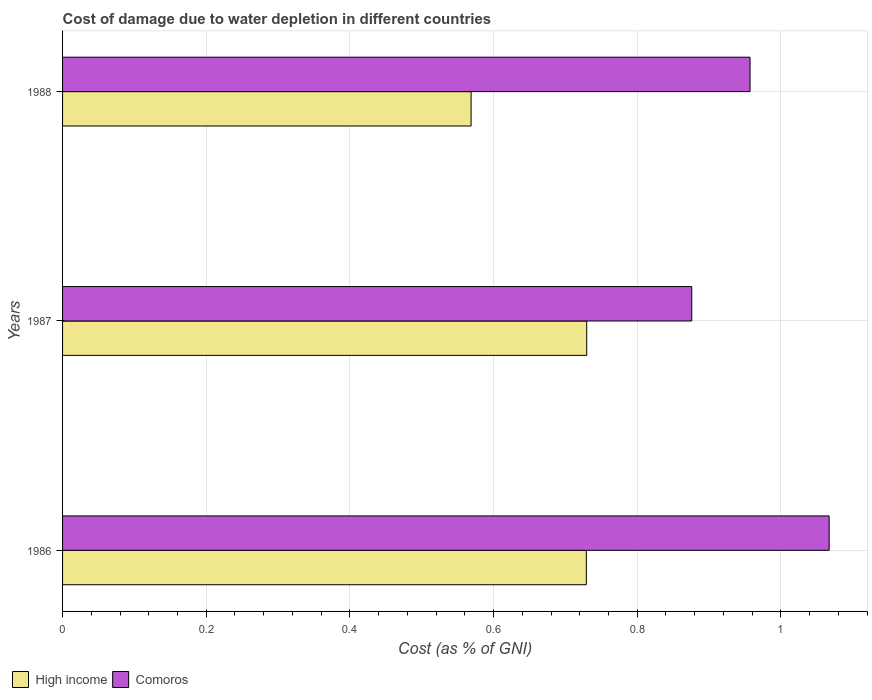How many different coloured bars are there?
Your answer should be very brief. 2. Are the number of bars on each tick of the Y-axis equal?
Make the answer very short. Yes. How many bars are there on the 3rd tick from the top?
Provide a succinct answer. 2. How many bars are there on the 1st tick from the bottom?
Provide a short and direct response. 2. What is the label of the 3rd group of bars from the top?
Your answer should be very brief. 1986. In how many cases, is the number of bars for a given year not equal to the number of legend labels?
Your answer should be very brief. 0. What is the cost of damage caused due to water depletion in Comoros in 1986?
Your answer should be very brief. 1.07. Across all years, what is the maximum cost of damage caused due to water depletion in High income?
Make the answer very short. 0.73. Across all years, what is the minimum cost of damage caused due to water depletion in Comoros?
Give a very brief answer. 0.88. In which year was the cost of damage caused due to water depletion in High income maximum?
Your answer should be very brief. 1987. In which year was the cost of damage caused due to water depletion in Comoros minimum?
Offer a very short reply. 1987. What is the total cost of damage caused due to water depletion in Comoros in the graph?
Provide a succinct answer. 2.9. What is the difference between the cost of damage caused due to water depletion in High income in 1987 and that in 1988?
Provide a short and direct response. 0.16. What is the difference between the cost of damage caused due to water depletion in Comoros in 1988 and the cost of damage caused due to water depletion in High income in 1986?
Your response must be concise. 0.23. What is the average cost of damage caused due to water depletion in High income per year?
Provide a succinct answer. 0.68. In the year 1986, what is the difference between the cost of damage caused due to water depletion in High income and cost of damage caused due to water depletion in Comoros?
Make the answer very short. -0.34. In how many years, is the cost of damage caused due to water depletion in Comoros greater than 0.92 %?
Provide a succinct answer. 2. What is the ratio of the cost of damage caused due to water depletion in Comoros in 1987 to that in 1988?
Offer a very short reply. 0.92. Is the cost of damage caused due to water depletion in High income in 1987 less than that in 1988?
Offer a terse response. No. Is the difference between the cost of damage caused due to water depletion in High income in 1987 and 1988 greater than the difference between the cost of damage caused due to water depletion in Comoros in 1987 and 1988?
Ensure brevity in your answer.  Yes. What is the difference between the highest and the second highest cost of damage caused due to water depletion in Comoros?
Give a very brief answer. 0.11. What is the difference between the highest and the lowest cost of damage caused due to water depletion in Comoros?
Ensure brevity in your answer.  0.19. Is the sum of the cost of damage caused due to water depletion in High income in 1987 and 1988 greater than the maximum cost of damage caused due to water depletion in Comoros across all years?
Your answer should be very brief. Yes. What does the 2nd bar from the bottom in 1987 represents?
Offer a terse response. Comoros. Are all the bars in the graph horizontal?
Keep it short and to the point. Yes. Does the graph contain any zero values?
Your answer should be compact. No. Does the graph contain grids?
Offer a very short reply. Yes. Where does the legend appear in the graph?
Provide a succinct answer. Bottom left. How many legend labels are there?
Give a very brief answer. 2. How are the legend labels stacked?
Offer a very short reply. Horizontal. What is the title of the graph?
Your answer should be compact. Cost of damage due to water depletion in different countries. What is the label or title of the X-axis?
Offer a very short reply. Cost (as % of GNI). What is the Cost (as % of GNI) of High income in 1986?
Your response must be concise. 0.73. What is the Cost (as % of GNI) in Comoros in 1986?
Your answer should be very brief. 1.07. What is the Cost (as % of GNI) of High income in 1987?
Offer a terse response. 0.73. What is the Cost (as % of GNI) of Comoros in 1987?
Your response must be concise. 0.88. What is the Cost (as % of GNI) in High income in 1988?
Your answer should be compact. 0.57. What is the Cost (as % of GNI) in Comoros in 1988?
Provide a succinct answer. 0.96. Across all years, what is the maximum Cost (as % of GNI) of High income?
Keep it short and to the point. 0.73. Across all years, what is the maximum Cost (as % of GNI) in Comoros?
Provide a succinct answer. 1.07. Across all years, what is the minimum Cost (as % of GNI) of High income?
Give a very brief answer. 0.57. Across all years, what is the minimum Cost (as % of GNI) in Comoros?
Offer a very short reply. 0.88. What is the total Cost (as % of GNI) of High income in the graph?
Your answer should be compact. 2.03. What is the total Cost (as % of GNI) in Comoros in the graph?
Your answer should be compact. 2.9. What is the difference between the Cost (as % of GNI) in High income in 1986 and that in 1987?
Give a very brief answer. -0. What is the difference between the Cost (as % of GNI) in Comoros in 1986 and that in 1987?
Make the answer very short. 0.19. What is the difference between the Cost (as % of GNI) in High income in 1986 and that in 1988?
Your response must be concise. 0.16. What is the difference between the Cost (as % of GNI) of Comoros in 1986 and that in 1988?
Keep it short and to the point. 0.11. What is the difference between the Cost (as % of GNI) of High income in 1987 and that in 1988?
Make the answer very short. 0.16. What is the difference between the Cost (as % of GNI) of Comoros in 1987 and that in 1988?
Your response must be concise. -0.08. What is the difference between the Cost (as % of GNI) of High income in 1986 and the Cost (as % of GNI) of Comoros in 1987?
Give a very brief answer. -0.15. What is the difference between the Cost (as % of GNI) in High income in 1986 and the Cost (as % of GNI) in Comoros in 1988?
Offer a very short reply. -0.23. What is the difference between the Cost (as % of GNI) in High income in 1987 and the Cost (as % of GNI) in Comoros in 1988?
Make the answer very short. -0.23. What is the average Cost (as % of GNI) of High income per year?
Your answer should be compact. 0.68. What is the average Cost (as % of GNI) in Comoros per year?
Your answer should be compact. 0.97. In the year 1986, what is the difference between the Cost (as % of GNI) of High income and Cost (as % of GNI) of Comoros?
Provide a short and direct response. -0.34. In the year 1987, what is the difference between the Cost (as % of GNI) in High income and Cost (as % of GNI) in Comoros?
Make the answer very short. -0.15. In the year 1988, what is the difference between the Cost (as % of GNI) in High income and Cost (as % of GNI) in Comoros?
Offer a terse response. -0.39. What is the ratio of the Cost (as % of GNI) of Comoros in 1986 to that in 1987?
Make the answer very short. 1.22. What is the ratio of the Cost (as % of GNI) of High income in 1986 to that in 1988?
Your response must be concise. 1.28. What is the ratio of the Cost (as % of GNI) in Comoros in 1986 to that in 1988?
Keep it short and to the point. 1.12. What is the ratio of the Cost (as % of GNI) in High income in 1987 to that in 1988?
Offer a terse response. 1.28. What is the ratio of the Cost (as % of GNI) of Comoros in 1987 to that in 1988?
Ensure brevity in your answer.  0.92. What is the difference between the highest and the second highest Cost (as % of GNI) of Comoros?
Give a very brief answer. 0.11. What is the difference between the highest and the lowest Cost (as % of GNI) of High income?
Ensure brevity in your answer.  0.16. What is the difference between the highest and the lowest Cost (as % of GNI) in Comoros?
Your response must be concise. 0.19. 